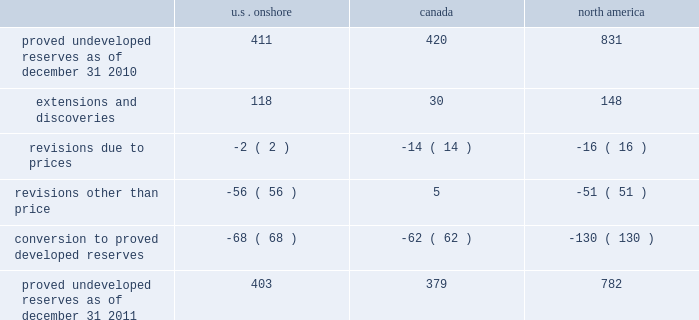Devon energy corporation and subsidiaries notes to consolidated financial statements 2014 ( continued ) proved undeveloped reserves the table presents the changes in our total proved undeveloped reserves during 2011 ( in mmboe ) . .
At december 31 , 2011 , devon had 782 mmboe of proved undeveloped reserves .
This represents a 6% ( 6 % ) decrease as compared to 2010 and represents 26% ( 26 % ) of its total proved reserves .
Drilling activities increased devon 2019s proved undeveloped reserves 148 mmboe and resulted in the conversion of 130 mmboe , or 16% ( 16 % ) , of the 2010 proved undeveloped reserves to proved developed reserves .
Additionally , revisions other than price decreased devon 2019s proved undeveloped reserves 51 mmboe primarily due to its evaluation of certain u.s .
Onshore dry-gas areas , which it does not expect to develop in the next five years .
The largest revisions relate to the dry-gas areas at carthage in east texas and the barnett shale in north texas .
A significant amount of devon 2019s proved undeveloped reserves at the end of 2011 largely related to its jackfish operations .
At december 31 , 2011 and 2010 , devon 2019s jackfish proved undeveloped reserves were 367 mmboe and 396 mmboe , respectively .
Development schedules for the jackfish reserves are primarily controlled by the need to keep the processing plants at their 35000 barrel daily facility capacity .
Processing plant capacity is controlled by factors such as total steam processing capacity , steam-oil ratios and air quality discharge permits .
As a result , these reserves are classified as proved undeveloped for more than five years .
Currently , the development schedule for these reserves extends though the year 2025 .
Price revisions 2011 2014reserves decreased 21 mmboe due to lower gas prices and higher oil prices .
The higher oil prices increased devon 2019s canadian royalty burden , which reduced devon 2019s oil reserves .
2010 2014reserves increased 72 mmboe due to higher gas prices , partially offset by the effect of higher oil prices .
The higher oil prices increased devon 2019s canadian royalty burden , which reduced devon 2019s oil reserves .
Of the 72 mmboe price revisions , 43 mmboe related to the barnett shale and 22 mmboe related to the rocky mountain area .
2009 2014reserves increased 177 mmboe due to higher oil prices , partially offset by lower gas prices .
The increase in oil reserves primarily related to devon 2019s jackfish thermal heavy oil reserves in canada .
At the end of 2008 , 331 mmboe of reserves related to jackfish were not considered proved .
However , due to higher prices , these reserves were considered proved as of december 31 , 2009 .
Significantly lower gas prices caused devon 2019s reserves to decrease 116 mmboe , which primarily related to its u.s .
Reserves .
Revisions other than price total revisions other than price for 2011 primarily related to devon 2019s evaluation of certain dry gas regions noted in the proved undeveloped reserves discussion above .
Total revisions other than price for 2010 and 2009 primarily related to devon 2019s drilling and development in the barnett shale. .
What was the percentage change in total proved undeveloped reserves for u.s . onshore from 2010 to 2011? 
Computations: ((403 - 411) / 411)
Answer: -0.01946. 